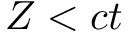<formula> <loc_0><loc_0><loc_500><loc_500>Z < c t</formula> 